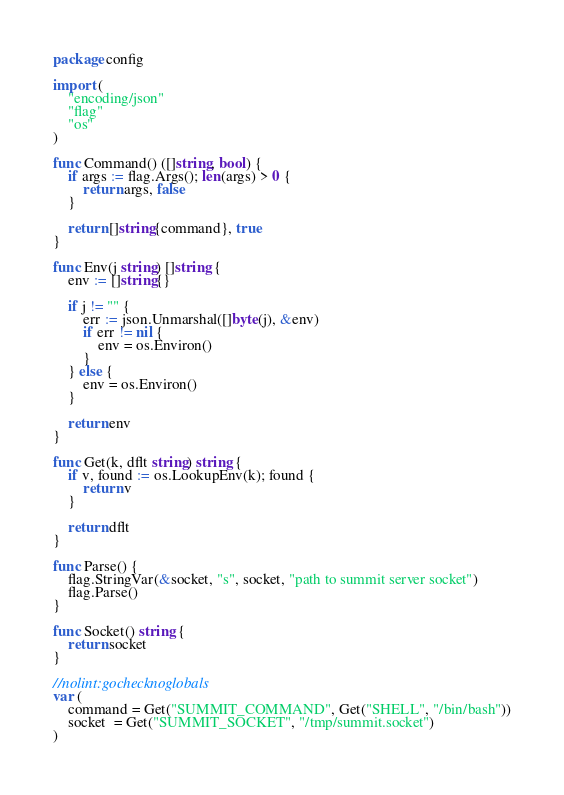Convert code to text. <code><loc_0><loc_0><loc_500><loc_500><_Go_>package config

import (
	"encoding/json"
	"flag"
	"os"
)

func Command() ([]string, bool) {
	if args := flag.Args(); len(args) > 0 {
		return args, false
	}

	return []string{command}, true
}

func Env(j string) []string {
	env := []string{}

	if j != "" {
		err := json.Unmarshal([]byte(j), &env)
		if err != nil {
			env = os.Environ()
		}
	} else {
		env = os.Environ()
	}

	return env
}

func Get(k, dflt string) string {
	if v, found := os.LookupEnv(k); found {
		return v
	}

	return dflt
}

func Parse() {
	flag.StringVar(&socket, "s", socket, "path to summit server socket")
	flag.Parse()
}

func Socket() string {
	return socket
}

//nolint:gochecknoglobals
var (
	command = Get("SUMMIT_COMMAND", Get("SHELL", "/bin/bash"))
	socket  = Get("SUMMIT_SOCKET", "/tmp/summit.socket")
)
</code> 